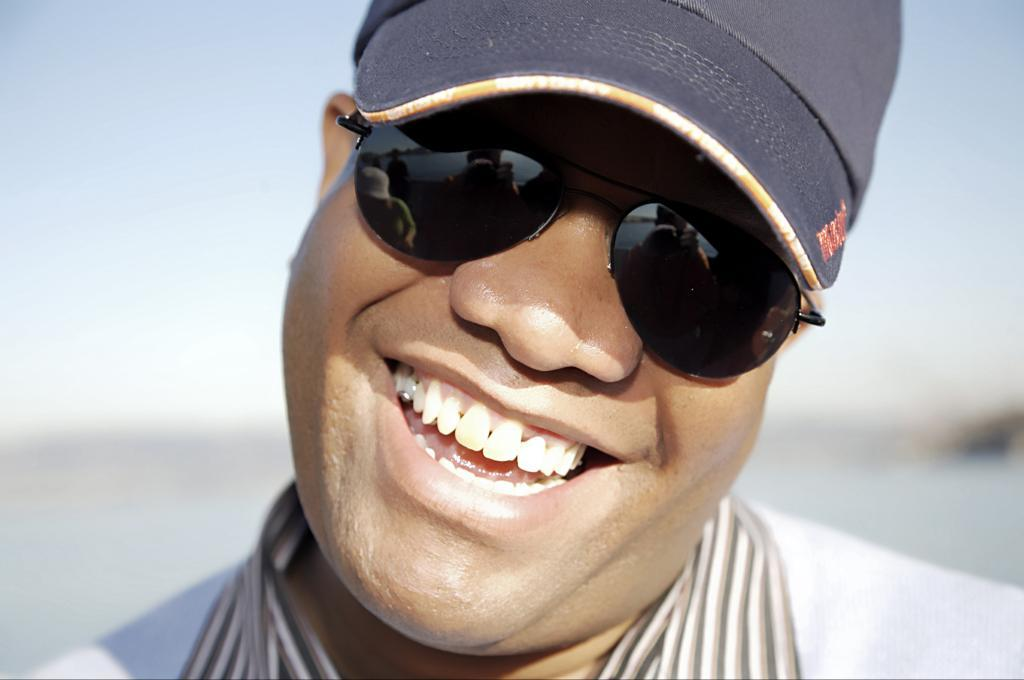Who or what is present in the image? There is a person in the image. What is the person's facial expression? The person is smiling. What accessories is the person wearing? The person is wearing spectacles and a cap. Can you describe the background of the image? The background of the image is blurred. How many matches are visible in the image? There are no matches present in the image. What type of van is parked in the background of the image? There is no van present in the image. 